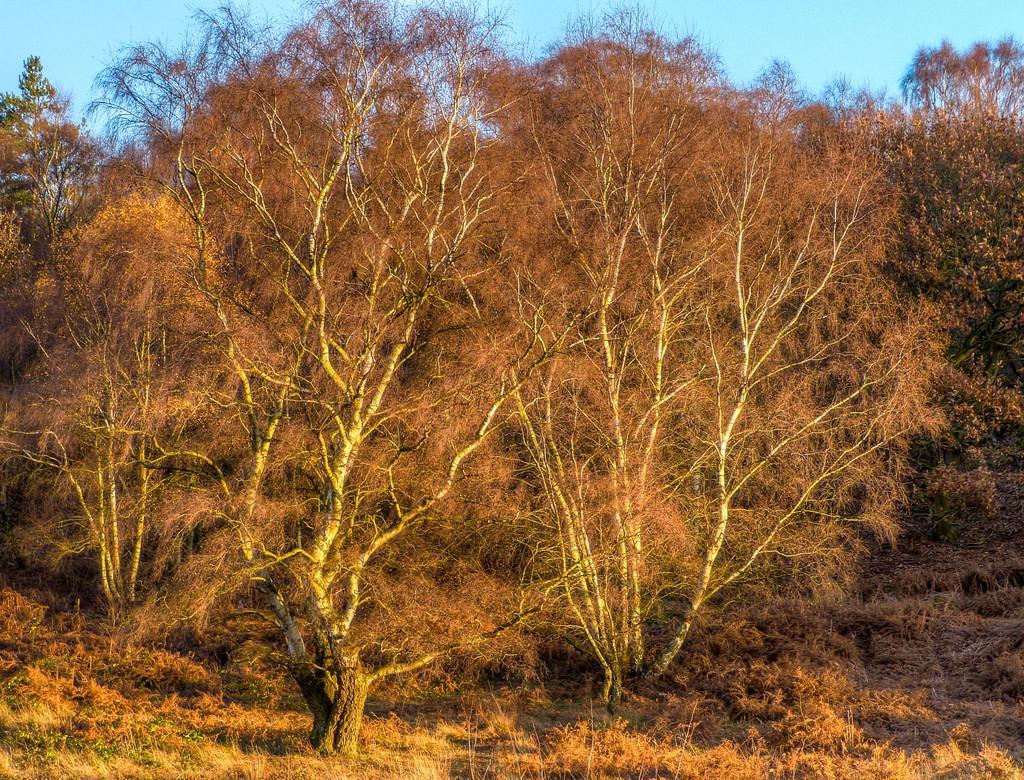In one or two sentences, can you explain what this image depicts? In this picture we can see trees, grass on the ground and we can see sky in the background. 